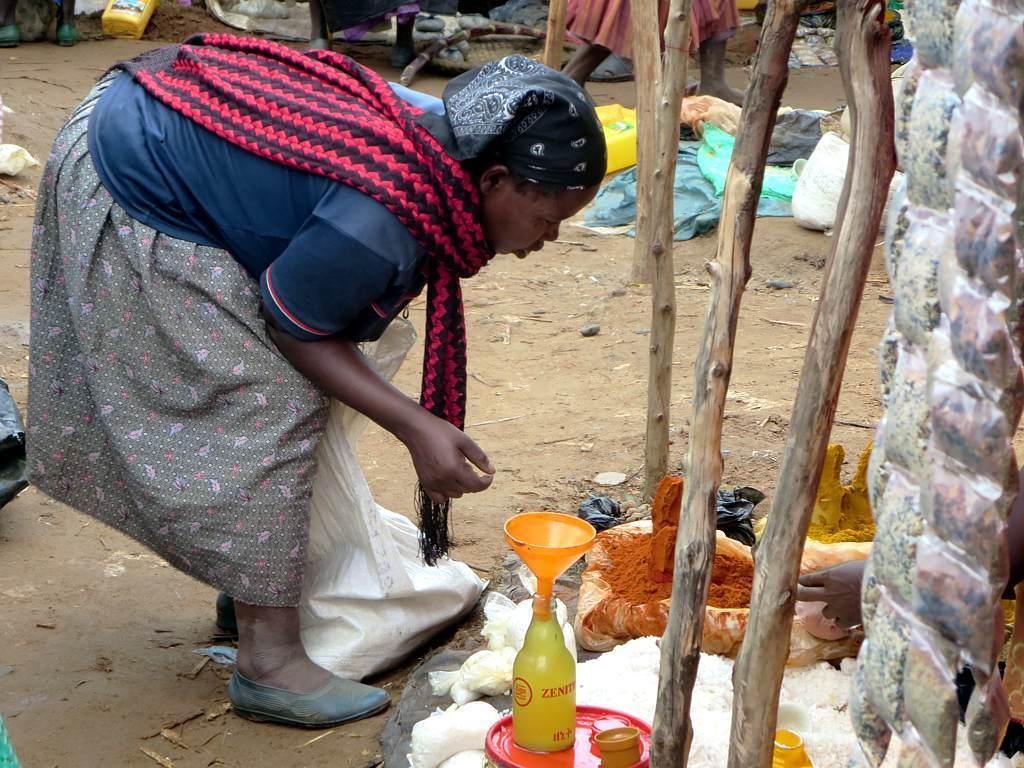In one or two sentences, can you explain what this image depicts? In this picture we can see a woman on the ground, here we can see bottle, wooden poles, funnel, clothes, person's legs, cans and some objects. 